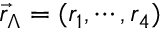Convert formula to latex. <formula><loc_0><loc_0><loc_500><loc_500>\vec { r } _ { \Lambda } = ( r _ { 1 } , \cdots , r _ { 4 } )</formula> 